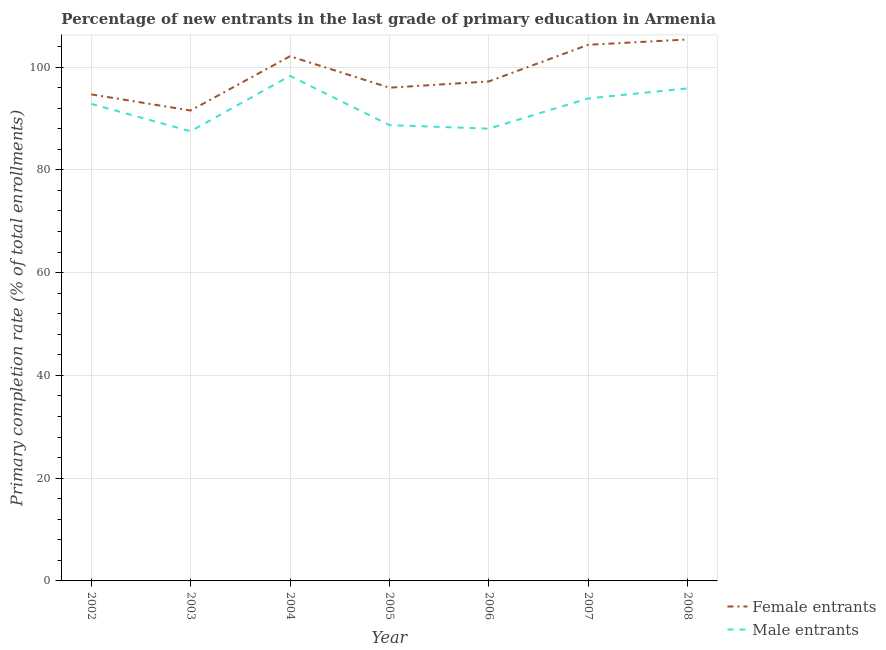What is the primary completion rate of female entrants in 2007?
Ensure brevity in your answer.  104.33. Across all years, what is the maximum primary completion rate of male entrants?
Ensure brevity in your answer.  98.27. Across all years, what is the minimum primary completion rate of female entrants?
Provide a succinct answer. 91.53. In which year was the primary completion rate of male entrants maximum?
Give a very brief answer. 2004. In which year was the primary completion rate of female entrants minimum?
Your answer should be compact. 2003. What is the total primary completion rate of male entrants in the graph?
Provide a succinct answer. 645.02. What is the difference between the primary completion rate of male entrants in 2003 and that in 2005?
Your response must be concise. -1.2. What is the difference between the primary completion rate of male entrants in 2007 and the primary completion rate of female entrants in 2005?
Your answer should be very brief. -2.09. What is the average primary completion rate of male entrants per year?
Offer a very short reply. 92.15. In the year 2003, what is the difference between the primary completion rate of female entrants and primary completion rate of male entrants?
Offer a terse response. 4.04. In how many years, is the primary completion rate of male entrants greater than 4 %?
Offer a very short reply. 7. What is the ratio of the primary completion rate of female entrants in 2006 to that in 2007?
Offer a very short reply. 0.93. Is the primary completion rate of male entrants in 2005 less than that in 2006?
Offer a very short reply. No. Is the difference between the primary completion rate of female entrants in 2002 and 2008 greater than the difference between the primary completion rate of male entrants in 2002 and 2008?
Your response must be concise. No. What is the difference between the highest and the second highest primary completion rate of female entrants?
Provide a short and direct response. 1.03. What is the difference between the highest and the lowest primary completion rate of female entrants?
Provide a short and direct response. 13.83. In how many years, is the primary completion rate of male entrants greater than the average primary completion rate of male entrants taken over all years?
Your answer should be very brief. 4. Is the sum of the primary completion rate of male entrants in 2002 and 2008 greater than the maximum primary completion rate of female entrants across all years?
Provide a succinct answer. Yes. Does the primary completion rate of female entrants monotonically increase over the years?
Give a very brief answer. No. Is the primary completion rate of female entrants strictly greater than the primary completion rate of male entrants over the years?
Your response must be concise. Yes. Is the primary completion rate of male entrants strictly less than the primary completion rate of female entrants over the years?
Give a very brief answer. Yes. How many lines are there?
Give a very brief answer. 2. How many years are there in the graph?
Give a very brief answer. 7. Does the graph contain any zero values?
Keep it short and to the point. No. Where does the legend appear in the graph?
Offer a very short reply. Bottom right. How many legend labels are there?
Ensure brevity in your answer.  2. What is the title of the graph?
Provide a short and direct response. Percentage of new entrants in the last grade of primary education in Armenia. Does "Imports" appear as one of the legend labels in the graph?
Make the answer very short. No. What is the label or title of the X-axis?
Provide a succinct answer. Year. What is the label or title of the Y-axis?
Make the answer very short. Primary completion rate (% of total enrollments). What is the Primary completion rate (% of total enrollments) of Female entrants in 2002?
Give a very brief answer. 94.68. What is the Primary completion rate (% of total enrollments) in Male entrants in 2002?
Ensure brevity in your answer.  92.83. What is the Primary completion rate (% of total enrollments) in Female entrants in 2003?
Your response must be concise. 91.53. What is the Primary completion rate (% of total enrollments) of Male entrants in 2003?
Your response must be concise. 87.49. What is the Primary completion rate (% of total enrollments) of Female entrants in 2004?
Your response must be concise. 102.09. What is the Primary completion rate (% of total enrollments) of Male entrants in 2004?
Your response must be concise. 98.27. What is the Primary completion rate (% of total enrollments) in Female entrants in 2005?
Provide a short and direct response. 95.97. What is the Primary completion rate (% of total enrollments) in Male entrants in 2005?
Your answer should be compact. 88.7. What is the Primary completion rate (% of total enrollments) of Female entrants in 2006?
Provide a succinct answer. 97.19. What is the Primary completion rate (% of total enrollments) in Male entrants in 2006?
Your response must be concise. 88. What is the Primary completion rate (% of total enrollments) in Female entrants in 2007?
Make the answer very short. 104.33. What is the Primary completion rate (% of total enrollments) of Male entrants in 2007?
Provide a succinct answer. 93.88. What is the Primary completion rate (% of total enrollments) in Female entrants in 2008?
Give a very brief answer. 105.36. What is the Primary completion rate (% of total enrollments) of Male entrants in 2008?
Keep it short and to the point. 95.84. Across all years, what is the maximum Primary completion rate (% of total enrollments) of Female entrants?
Your response must be concise. 105.36. Across all years, what is the maximum Primary completion rate (% of total enrollments) of Male entrants?
Provide a short and direct response. 98.27. Across all years, what is the minimum Primary completion rate (% of total enrollments) in Female entrants?
Provide a short and direct response. 91.53. Across all years, what is the minimum Primary completion rate (% of total enrollments) in Male entrants?
Offer a very short reply. 87.49. What is the total Primary completion rate (% of total enrollments) in Female entrants in the graph?
Your answer should be compact. 691.16. What is the total Primary completion rate (% of total enrollments) in Male entrants in the graph?
Offer a terse response. 645.02. What is the difference between the Primary completion rate (% of total enrollments) in Female entrants in 2002 and that in 2003?
Keep it short and to the point. 3.14. What is the difference between the Primary completion rate (% of total enrollments) in Male entrants in 2002 and that in 2003?
Give a very brief answer. 5.34. What is the difference between the Primary completion rate (% of total enrollments) in Female entrants in 2002 and that in 2004?
Keep it short and to the point. -7.42. What is the difference between the Primary completion rate (% of total enrollments) of Male entrants in 2002 and that in 2004?
Make the answer very short. -5.44. What is the difference between the Primary completion rate (% of total enrollments) in Female entrants in 2002 and that in 2005?
Ensure brevity in your answer.  -1.3. What is the difference between the Primary completion rate (% of total enrollments) of Male entrants in 2002 and that in 2005?
Give a very brief answer. 4.13. What is the difference between the Primary completion rate (% of total enrollments) of Female entrants in 2002 and that in 2006?
Your response must be concise. -2.52. What is the difference between the Primary completion rate (% of total enrollments) of Male entrants in 2002 and that in 2006?
Keep it short and to the point. 4.83. What is the difference between the Primary completion rate (% of total enrollments) of Female entrants in 2002 and that in 2007?
Offer a terse response. -9.65. What is the difference between the Primary completion rate (% of total enrollments) of Male entrants in 2002 and that in 2007?
Keep it short and to the point. -1.05. What is the difference between the Primary completion rate (% of total enrollments) of Female entrants in 2002 and that in 2008?
Provide a short and direct response. -10.68. What is the difference between the Primary completion rate (% of total enrollments) in Male entrants in 2002 and that in 2008?
Give a very brief answer. -3.01. What is the difference between the Primary completion rate (% of total enrollments) of Female entrants in 2003 and that in 2004?
Your answer should be very brief. -10.56. What is the difference between the Primary completion rate (% of total enrollments) of Male entrants in 2003 and that in 2004?
Keep it short and to the point. -10.78. What is the difference between the Primary completion rate (% of total enrollments) in Female entrants in 2003 and that in 2005?
Provide a short and direct response. -4.44. What is the difference between the Primary completion rate (% of total enrollments) of Male entrants in 2003 and that in 2005?
Keep it short and to the point. -1.2. What is the difference between the Primary completion rate (% of total enrollments) of Female entrants in 2003 and that in 2006?
Provide a short and direct response. -5.66. What is the difference between the Primary completion rate (% of total enrollments) of Male entrants in 2003 and that in 2006?
Make the answer very short. -0.51. What is the difference between the Primary completion rate (% of total enrollments) of Female entrants in 2003 and that in 2007?
Provide a short and direct response. -12.79. What is the difference between the Primary completion rate (% of total enrollments) in Male entrants in 2003 and that in 2007?
Ensure brevity in your answer.  -6.39. What is the difference between the Primary completion rate (% of total enrollments) in Female entrants in 2003 and that in 2008?
Your answer should be compact. -13.83. What is the difference between the Primary completion rate (% of total enrollments) of Male entrants in 2003 and that in 2008?
Your answer should be compact. -8.35. What is the difference between the Primary completion rate (% of total enrollments) in Female entrants in 2004 and that in 2005?
Your answer should be very brief. 6.12. What is the difference between the Primary completion rate (% of total enrollments) in Male entrants in 2004 and that in 2005?
Your response must be concise. 9.58. What is the difference between the Primary completion rate (% of total enrollments) in Female entrants in 2004 and that in 2006?
Make the answer very short. 4.9. What is the difference between the Primary completion rate (% of total enrollments) of Male entrants in 2004 and that in 2006?
Keep it short and to the point. 10.27. What is the difference between the Primary completion rate (% of total enrollments) in Female entrants in 2004 and that in 2007?
Provide a succinct answer. -2.23. What is the difference between the Primary completion rate (% of total enrollments) in Male entrants in 2004 and that in 2007?
Your answer should be compact. 4.39. What is the difference between the Primary completion rate (% of total enrollments) of Female entrants in 2004 and that in 2008?
Offer a terse response. -3.27. What is the difference between the Primary completion rate (% of total enrollments) of Male entrants in 2004 and that in 2008?
Provide a succinct answer. 2.43. What is the difference between the Primary completion rate (% of total enrollments) in Female entrants in 2005 and that in 2006?
Provide a succinct answer. -1.22. What is the difference between the Primary completion rate (% of total enrollments) in Male entrants in 2005 and that in 2006?
Give a very brief answer. 0.69. What is the difference between the Primary completion rate (% of total enrollments) in Female entrants in 2005 and that in 2007?
Keep it short and to the point. -8.35. What is the difference between the Primary completion rate (% of total enrollments) in Male entrants in 2005 and that in 2007?
Your answer should be compact. -5.19. What is the difference between the Primary completion rate (% of total enrollments) of Female entrants in 2005 and that in 2008?
Your answer should be compact. -9.39. What is the difference between the Primary completion rate (% of total enrollments) of Male entrants in 2005 and that in 2008?
Your answer should be compact. -7.15. What is the difference between the Primary completion rate (% of total enrollments) of Female entrants in 2006 and that in 2007?
Offer a terse response. -7.13. What is the difference between the Primary completion rate (% of total enrollments) in Male entrants in 2006 and that in 2007?
Your response must be concise. -5.88. What is the difference between the Primary completion rate (% of total enrollments) in Female entrants in 2006 and that in 2008?
Provide a short and direct response. -8.17. What is the difference between the Primary completion rate (% of total enrollments) of Male entrants in 2006 and that in 2008?
Offer a terse response. -7.84. What is the difference between the Primary completion rate (% of total enrollments) of Female entrants in 2007 and that in 2008?
Give a very brief answer. -1.03. What is the difference between the Primary completion rate (% of total enrollments) in Male entrants in 2007 and that in 2008?
Provide a succinct answer. -1.96. What is the difference between the Primary completion rate (% of total enrollments) of Female entrants in 2002 and the Primary completion rate (% of total enrollments) of Male entrants in 2003?
Your response must be concise. 7.18. What is the difference between the Primary completion rate (% of total enrollments) of Female entrants in 2002 and the Primary completion rate (% of total enrollments) of Male entrants in 2004?
Your answer should be compact. -3.6. What is the difference between the Primary completion rate (% of total enrollments) of Female entrants in 2002 and the Primary completion rate (% of total enrollments) of Male entrants in 2005?
Offer a terse response. 5.98. What is the difference between the Primary completion rate (% of total enrollments) in Female entrants in 2002 and the Primary completion rate (% of total enrollments) in Male entrants in 2006?
Provide a short and direct response. 6.67. What is the difference between the Primary completion rate (% of total enrollments) of Female entrants in 2002 and the Primary completion rate (% of total enrollments) of Male entrants in 2007?
Provide a short and direct response. 0.79. What is the difference between the Primary completion rate (% of total enrollments) in Female entrants in 2002 and the Primary completion rate (% of total enrollments) in Male entrants in 2008?
Your answer should be compact. -1.17. What is the difference between the Primary completion rate (% of total enrollments) of Female entrants in 2003 and the Primary completion rate (% of total enrollments) of Male entrants in 2004?
Your response must be concise. -6.74. What is the difference between the Primary completion rate (% of total enrollments) in Female entrants in 2003 and the Primary completion rate (% of total enrollments) in Male entrants in 2005?
Provide a succinct answer. 2.84. What is the difference between the Primary completion rate (% of total enrollments) in Female entrants in 2003 and the Primary completion rate (% of total enrollments) in Male entrants in 2006?
Your answer should be compact. 3.53. What is the difference between the Primary completion rate (% of total enrollments) in Female entrants in 2003 and the Primary completion rate (% of total enrollments) in Male entrants in 2007?
Provide a succinct answer. -2.35. What is the difference between the Primary completion rate (% of total enrollments) in Female entrants in 2003 and the Primary completion rate (% of total enrollments) in Male entrants in 2008?
Your answer should be very brief. -4.31. What is the difference between the Primary completion rate (% of total enrollments) in Female entrants in 2004 and the Primary completion rate (% of total enrollments) in Male entrants in 2005?
Ensure brevity in your answer.  13.39. What is the difference between the Primary completion rate (% of total enrollments) in Female entrants in 2004 and the Primary completion rate (% of total enrollments) in Male entrants in 2006?
Make the answer very short. 14.09. What is the difference between the Primary completion rate (% of total enrollments) in Female entrants in 2004 and the Primary completion rate (% of total enrollments) in Male entrants in 2007?
Provide a succinct answer. 8.21. What is the difference between the Primary completion rate (% of total enrollments) in Female entrants in 2004 and the Primary completion rate (% of total enrollments) in Male entrants in 2008?
Provide a short and direct response. 6.25. What is the difference between the Primary completion rate (% of total enrollments) of Female entrants in 2005 and the Primary completion rate (% of total enrollments) of Male entrants in 2006?
Provide a short and direct response. 7.97. What is the difference between the Primary completion rate (% of total enrollments) of Female entrants in 2005 and the Primary completion rate (% of total enrollments) of Male entrants in 2007?
Offer a very short reply. 2.09. What is the difference between the Primary completion rate (% of total enrollments) of Female entrants in 2005 and the Primary completion rate (% of total enrollments) of Male entrants in 2008?
Keep it short and to the point. 0.13. What is the difference between the Primary completion rate (% of total enrollments) of Female entrants in 2006 and the Primary completion rate (% of total enrollments) of Male entrants in 2007?
Offer a very short reply. 3.31. What is the difference between the Primary completion rate (% of total enrollments) of Female entrants in 2006 and the Primary completion rate (% of total enrollments) of Male entrants in 2008?
Your answer should be compact. 1.35. What is the difference between the Primary completion rate (% of total enrollments) of Female entrants in 2007 and the Primary completion rate (% of total enrollments) of Male entrants in 2008?
Make the answer very short. 8.48. What is the average Primary completion rate (% of total enrollments) in Female entrants per year?
Your response must be concise. 98.74. What is the average Primary completion rate (% of total enrollments) of Male entrants per year?
Your response must be concise. 92.15. In the year 2002, what is the difference between the Primary completion rate (% of total enrollments) in Female entrants and Primary completion rate (% of total enrollments) in Male entrants?
Your response must be concise. 1.85. In the year 2003, what is the difference between the Primary completion rate (% of total enrollments) in Female entrants and Primary completion rate (% of total enrollments) in Male entrants?
Provide a short and direct response. 4.04. In the year 2004, what is the difference between the Primary completion rate (% of total enrollments) in Female entrants and Primary completion rate (% of total enrollments) in Male entrants?
Make the answer very short. 3.82. In the year 2005, what is the difference between the Primary completion rate (% of total enrollments) in Female entrants and Primary completion rate (% of total enrollments) in Male entrants?
Ensure brevity in your answer.  7.28. In the year 2006, what is the difference between the Primary completion rate (% of total enrollments) of Female entrants and Primary completion rate (% of total enrollments) of Male entrants?
Keep it short and to the point. 9.19. In the year 2007, what is the difference between the Primary completion rate (% of total enrollments) of Female entrants and Primary completion rate (% of total enrollments) of Male entrants?
Provide a short and direct response. 10.44. In the year 2008, what is the difference between the Primary completion rate (% of total enrollments) in Female entrants and Primary completion rate (% of total enrollments) in Male entrants?
Offer a terse response. 9.52. What is the ratio of the Primary completion rate (% of total enrollments) in Female entrants in 2002 to that in 2003?
Your answer should be very brief. 1.03. What is the ratio of the Primary completion rate (% of total enrollments) in Male entrants in 2002 to that in 2003?
Offer a terse response. 1.06. What is the ratio of the Primary completion rate (% of total enrollments) in Female entrants in 2002 to that in 2004?
Ensure brevity in your answer.  0.93. What is the ratio of the Primary completion rate (% of total enrollments) of Male entrants in 2002 to that in 2004?
Provide a short and direct response. 0.94. What is the ratio of the Primary completion rate (% of total enrollments) of Female entrants in 2002 to that in 2005?
Offer a very short reply. 0.99. What is the ratio of the Primary completion rate (% of total enrollments) in Male entrants in 2002 to that in 2005?
Provide a short and direct response. 1.05. What is the ratio of the Primary completion rate (% of total enrollments) of Female entrants in 2002 to that in 2006?
Your answer should be very brief. 0.97. What is the ratio of the Primary completion rate (% of total enrollments) of Male entrants in 2002 to that in 2006?
Make the answer very short. 1.05. What is the ratio of the Primary completion rate (% of total enrollments) of Female entrants in 2002 to that in 2007?
Offer a very short reply. 0.91. What is the ratio of the Primary completion rate (% of total enrollments) in Male entrants in 2002 to that in 2007?
Ensure brevity in your answer.  0.99. What is the ratio of the Primary completion rate (% of total enrollments) in Female entrants in 2002 to that in 2008?
Provide a succinct answer. 0.9. What is the ratio of the Primary completion rate (% of total enrollments) in Male entrants in 2002 to that in 2008?
Your answer should be very brief. 0.97. What is the ratio of the Primary completion rate (% of total enrollments) in Female entrants in 2003 to that in 2004?
Your answer should be compact. 0.9. What is the ratio of the Primary completion rate (% of total enrollments) in Male entrants in 2003 to that in 2004?
Offer a very short reply. 0.89. What is the ratio of the Primary completion rate (% of total enrollments) in Female entrants in 2003 to that in 2005?
Ensure brevity in your answer.  0.95. What is the ratio of the Primary completion rate (% of total enrollments) in Male entrants in 2003 to that in 2005?
Offer a terse response. 0.99. What is the ratio of the Primary completion rate (% of total enrollments) in Female entrants in 2003 to that in 2006?
Give a very brief answer. 0.94. What is the ratio of the Primary completion rate (% of total enrollments) of Male entrants in 2003 to that in 2006?
Keep it short and to the point. 0.99. What is the ratio of the Primary completion rate (% of total enrollments) of Female entrants in 2003 to that in 2007?
Give a very brief answer. 0.88. What is the ratio of the Primary completion rate (% of total enrollments) of Male entrants in 2003 to that in 2007?
Your response must be concise. 0.93. What is the ratio of the Primary completion rate (% of total enrollments) of Female entrants in 2003 to that in 2008?
Your answer should be compact. 0.87. What is the ratio of the Primary completion rate (% of total enrollments) in Male entrants in 2003 to that in 2008?
Provide a short and direct response. 0.91. What is the ratio of the Primary completion rate (% of total enrollments) in Female entrants in 2004 to that in 2005?
Offer a very short reply. 1.06. What is the ratio of the Primary completion rate (% of total enrollments) of Male entrants in 2004 to that in 2005?
Your answer should be compact. 1.11. What is the ratio of the Primary completion rate (% of total enrollments) of Female entrants in 2004 to that in 2006?
Make the answer very short. 1.05. What is the ratio of the Primary completion rate (% of total enrollments) of Male entrants in 2004 to that in 2006?
Your response must be concise. 1.12. What is the ratio of the Primary completion rate (% of total enrollments) in Female entrants in 2004 to that in 2007?
Offer a very short reply. 0.98. What is the ratio of the Primary completion rate (% of total enrollments) of Male entrants in 2004 to that in 2007?
Offer a terse response. 1.05. What is the ratio of the Primary completion rate (% of total enrollments) in Female entrants in 2004 to that in 2008?
Your answer should be compact. 0.97. What is the ratio of the Primary completion rate (% of total enrollments) in Male entrants in 2004 to that in 2008?
Provide a short and direct response. 1.03. What is the ratio of the Primary completion rate (% of total enrollments) of Female entrants in 2005 to that in 2006?
Offer a very short reply. 0.99. What is the ratio of the Primary completion rate (% of total enrollments) in Male entrants in 2005 to that in 2006?
Offer a terse response. 1.01. What is the ratio of the Primary completion rate (% of total enrollments) of Male entrants in 2005 to that in 2007?
Offer a terse response. 0.94. What is the ratio of the Primary completion rate (% of total enrollments) in Female entrants in 2005 to that in 2008?
Your answer should be very brief. 0.91. What is the ratio of the Primary completion rate (% of total enrollments) of Male entrants in 2005 to that in 2008?
Provide a succinct answer. 0.93. What is the ratio of the Primary completion rate (% of total enrollments) in Female entrants in 2006 to that in 2007?
Give a very brief answer. 0.93. What is the ratio of the Primary completion rate (% of total enrollments) in Male entrants in 2006 to that in 2007?
Offer a terse response. 0.94. What is the ratio of the Primary completion rate (% of total enrollments) of Female entrants in 2006 to that in 2008?
Your answer should be compact. 0.92. What is the ratio of the Primary completion rate (% of total enrollments) in Male entrants in 2006 to that in 2008?
Your response must be concise. 0.92. What is the ratio of the Primary completion rate (% of total enrollments) in Female entrants in 2007 to that in 2008?
Make the answer very short. 0.99. What is the ratio of the Primary completion rate (% of total enrollments) in Male entrants in 2007 to that in 2008?
Make the answer very short. 0.98. What is the difference between the highest and the second highest Primary completion rate (% of total enrollments) in Female entrants?
Your response must be concise. 1.03. What is the difference between the highest and the second highest Primary completion rate (% of total enrollments) of Male entrants?
Give a very brief answer. 2.43. What is the difference between the highest and the lowest Primary completion rate (% of total enrollments) in Female entrants?
Ensure brevity in your answer.  13.83. What is the difference between the highest and the lowest Primary completion rate (% of total enrollments) in Male entrants?
Offer a terse response. 10.78. 